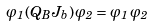<formula> <loc_0><loc_0><loc_500><loc_500>\varphi _ { 1 } \, ( Q _ { B } J _ { b } ) \, \varphi _ { 2 } = \varphi _ { 1 } \, \varphi _ { 2 }</formula> 